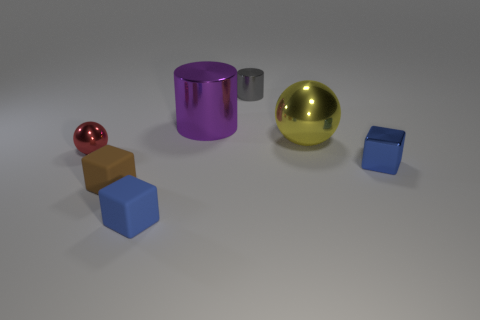What is the size of the rubber thing that is the same color as the shiny block?
Ensure brevity in your answer.  Small. What number of tiny objects are the same color as the metallic cube?
Give a very brief answer. 1. Do the blue cube that is on the right side of the gray shiny object and the shiny sphere that is behind the tiny red metallic ball have the same size?
Ensure brevity in your answer.  No. How many other things are the same shape as the small brown rubber object?
Make the answer very short. 2. What is the size of the shiny thing to the left of the small blue block that is on the left side of the tiny blue metal cube?
Offer a very short reply. Small. Are any small yellow rubber balls visible?
Your answer should be compact. No. There is a tiny thing that is behind the tiny red shiny sphere; what number of gray metal objects are in front of it?
Provide a short and direct response. 0. There is a small shiny thing behind the tiny red metallic thing; what is its shape?
Provide a short and direct response. Cylinder. What is the material of the sphere to the right of the tiny rubber thing that is left of the small blue block that is left of the big yellow thing?
Make the answer very short. Metal. How many other objects are the same size as the blue rubber object?
Offer a very short reply. 4. 